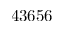Convert formula to latex. <formula><loc_0><loc_0><loc_500><loc_500>4 3 6 5 6</formula> 